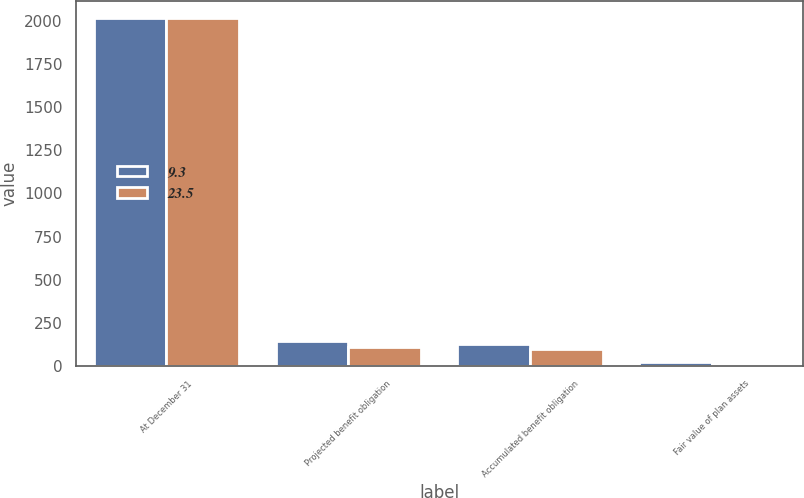<chart> <loc_0><loc_0><loc_500><loc_500><stacked_bar_chart><ecel><fcel>At December 31<fcel>Projected benefit obligation<fcel>Accumulated benefit obligation<fcel>Fair value of plan assets<nl><fcel>9.3<fcel>2017<fcel>142.5<fcel>124<fcel>23.5<nl><fcel>23.5<fcel>2016<fcel>110.2<fcel>100.4<fcel>9.3<nl></chart> 